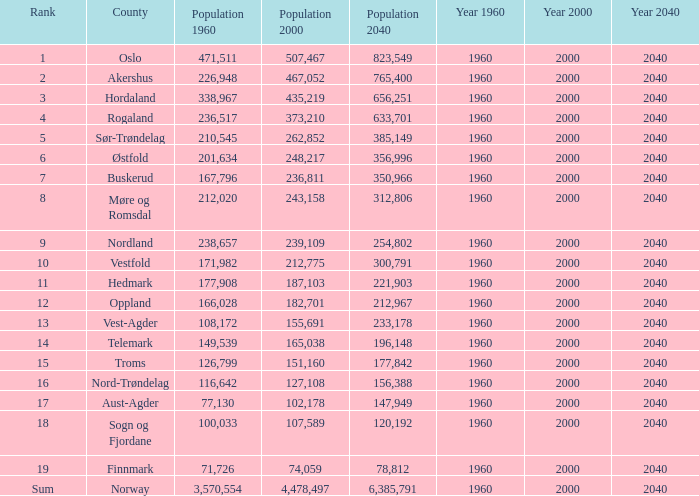What was Oslo's population in 1960, with a population of 507,467 in 2000? None. 